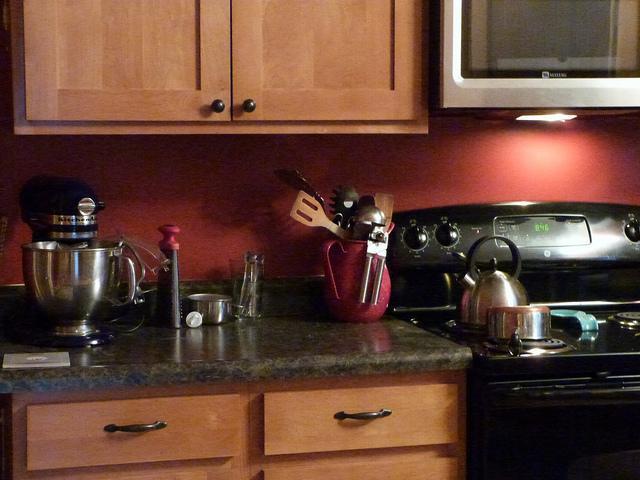How many microwaves are there?
Give a very brief answer. 1. 